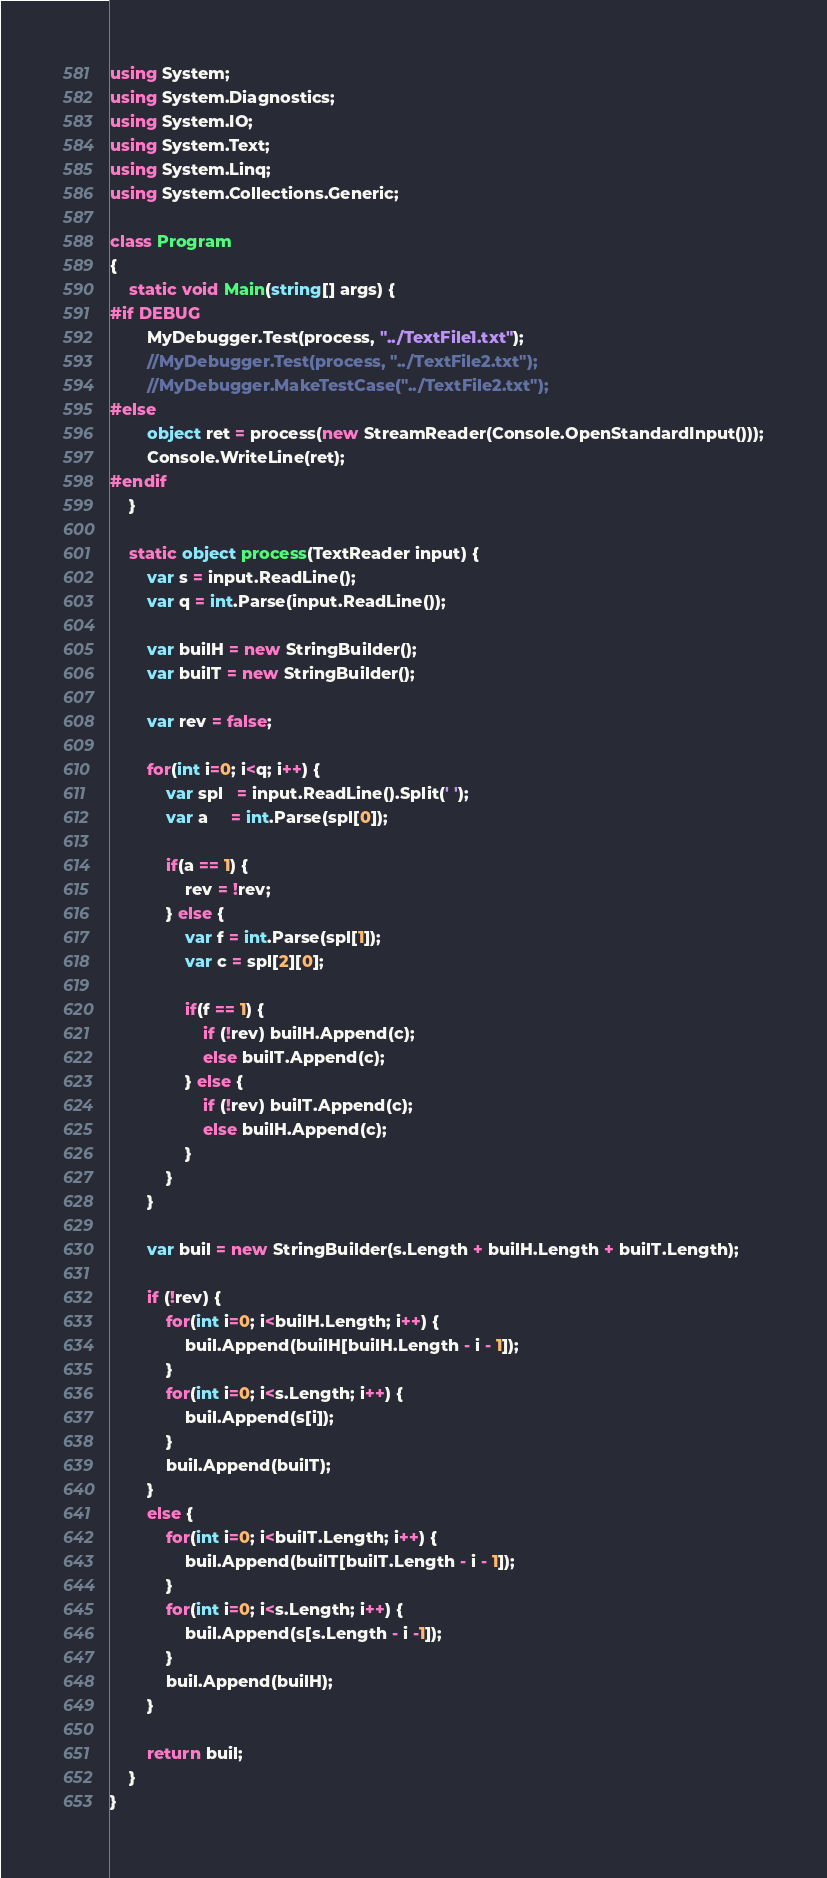Convert code to text. <code><loc_0><loc_0><loc_500><loc_500><_C#_>using System;
using System.Diagnostics;
using System.IO;
using System.Text;
using System.Linq;
using System.Collections.Generic;

class Program
{
    static void Main(string[] args) {
#if DEBUG
        MyDebugger.Test(process, "../TextFile1.txt");
        //MyDebugger.Test(process, "../TextFile2.txt");
        //MyDebugger.MakeTestCase("../TextFile2.txt");
#else
        object ret = process(new StreamReader(Console.OpenStandardInput()));
        Console.WriteLine(ret);
#endif
    }

    static object process(TextReader input) {
        var s = input.ReadLine();
        var q = int.Parse(input.ReadLine());

        var builH = new StringBuilder();
        var builT = new StringBuilder();

        var rev = false;

        for(int i=0; i<q; i++) {
            var spl   = input.ReadLine().Split(' ');
            var a     = int.Parse(spl[0]);

            if(a == 1) {
                rev = !rev;
            } else {
                var f = int.Parse(spl[1]);
                var c = spl[2][0];

                if(f == 1) {
                    if (!rev) builH.Append(c);
                    else builT.Append(c);
                } else {
                    if (!rev) builT.Append(c);
                    else builH.Append(c);
                }
            }
        }

        var buil = new StringBuilder(s.Length + builH.Length + builT.Length);

        if (!rev) {
            for(int i=0; i<builH.Length; i++) {
                buil.Append(builH[builH.Length - i - 1]);
            }
            for(int i=0; i<s.Length; i++) {
                buil.Append(s[i]);
            }
            buil.Append(builT);
        }
        else {
            for(int i=0; i<builT.Length; i++) {
                buil.Append(builT[builT.Length - i - 1]);
            }
            for(int i=0; i<s.Length; i++) {
                buil.Append(s[s.Length - i -1]);
            }
            buil.Append(builH);
        }

        return buil;
    }
}</code> 